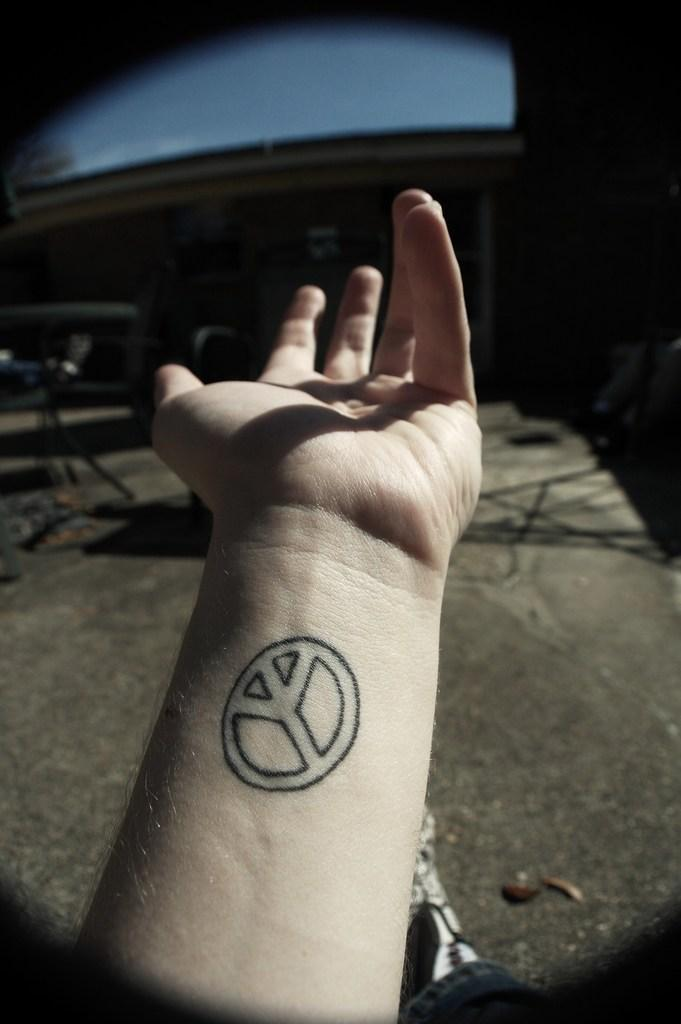What part of the body is visible in the image? There is a person's hand in the image. Are there any distinguishing features on the hand? Yes, there is a tattoo on the hand. What type of brass instrument is being played in the image? There is no brass instrument present in the image; it only features a person's hand with a tattoo. 